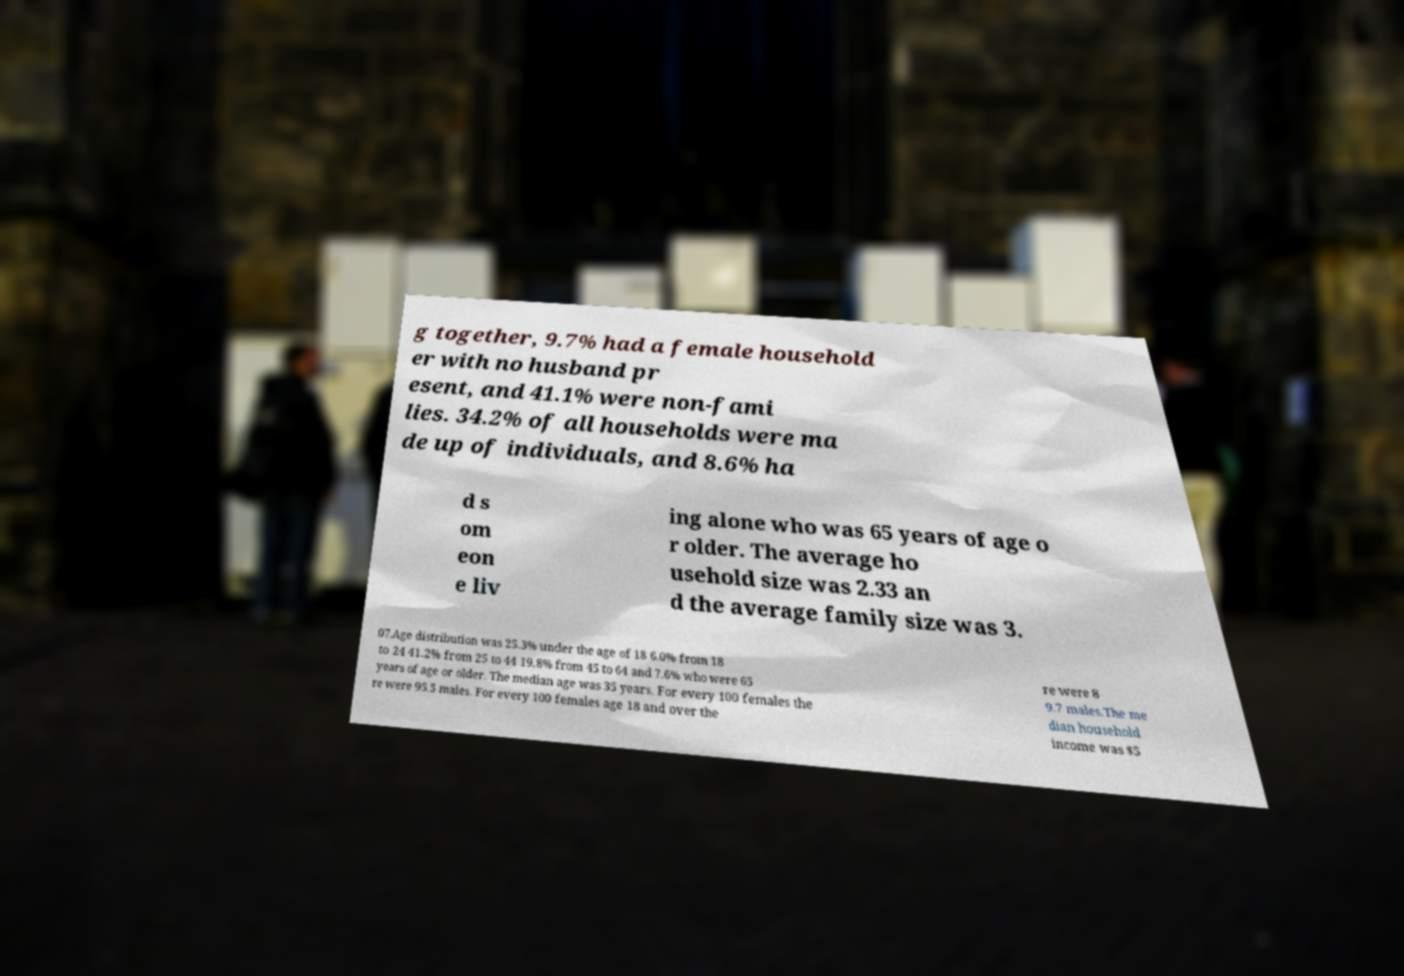Can you accurately transcribe the text from the provided image for me? g together, 9.7% had a female household er with no husband pr esent, and 41.1% were non-fami lies. 34.2% of all households were ma de up of individuals, and 8.6% ha d s om eon e liv ing alone who was 65 years of age o r older. The average ho usehold size was 2.33 an d the average family size was 3. 07.Age distribution was 25.3% under the age of 18 6.0% from 18 to 24 41.2% from 25 to 44 19.8% from 45 to 64 and 7.6% who were 65 years of age or older. The median age was 35 years. For every 100 females the re were 95.5 males. For every 100 females age 18 and over the re were 8 9.7 males.The me dian household income was $5 